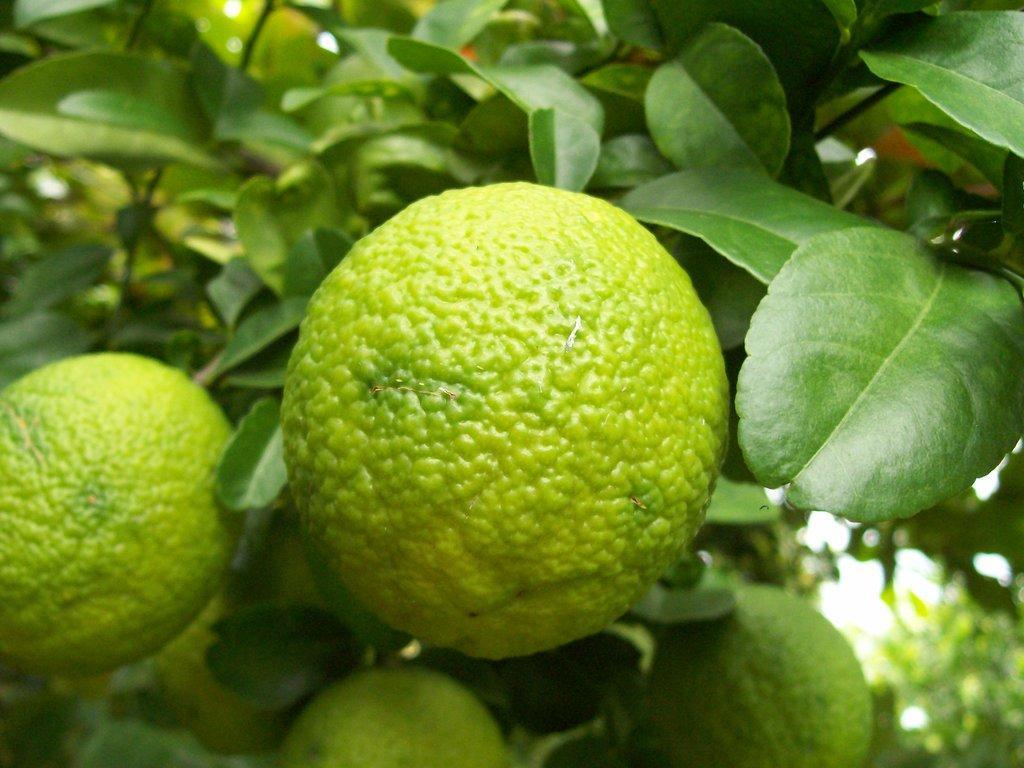How would you summarize this image in a sentence or two? In this image I can see few fruits which are green and yellow in color to the tree. I can see the sky in the background. 